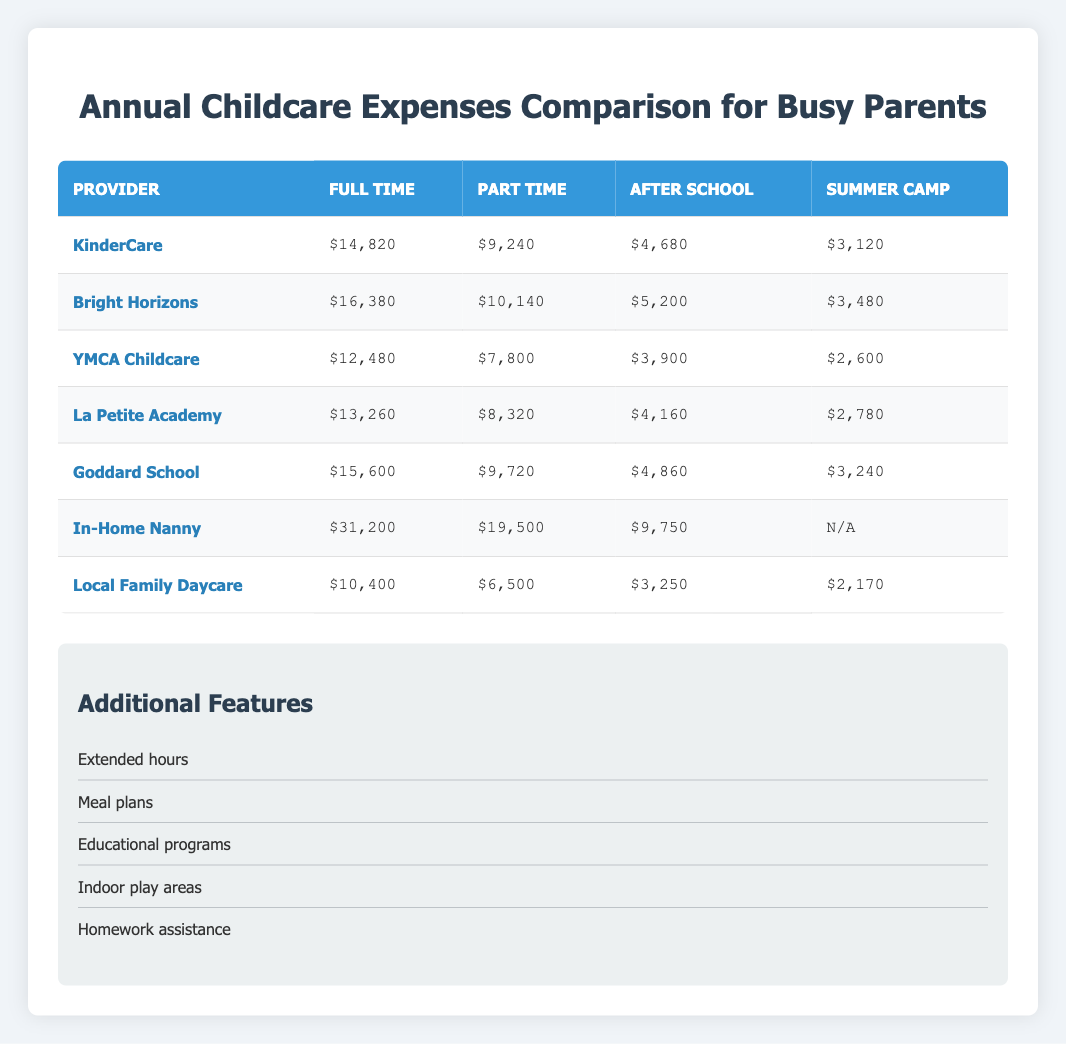What is the full-time expense for KinderCare? The table shows that the full-time expense for KinderCare is $14,820
Answer: $14,820 Which provider has the highest after school care expense? The highest after school care expense in the table is $9,750 from In-Home Nanny
Answer: $9,750 What is the total annual expense for Local Family Daycare for both full-time and part-time care? The total for Local Family Daycare is calculated by adding the full-time expense ($10,400) and the part-time expense ($6,500), resulting in $10,400 + $6,500 = $16,900
Answer: $16,900 Is the summer camp expense for La Petite Academy greater than that of YMCA Childcare? The summer camp expense for La Petite Academy is $2,780 and for YMCA Childcare, it is $2,600. Since $2,780 is greater than $2,600, the statement is true
Answer: Yes What is the average full-time expense among all providers listed? There are 7 providers with the following full-time expenses: $14,820, $16,380, $12,480, $13,260, $15,600, $31,200, $10,400. Adding these gives $14,820 + $16,380 + $12,480 + $13,260 + $15,600 + $31,200 + $10,400 = $114,140. Dividing by 7 providers gives an average of $114,140 / 7 = $16,348.57
Answer: $16,348.57 How much more does In-Home Nanny charge for full-time care compared to Local Family Daycare? To find the difference, subtract the full-time expense of Local Family Daycare ($10,400) from that of In-Home Nanny ($31,200). The calculation is $31,200 - $10,400 = $20,800
Answer: $20,800 